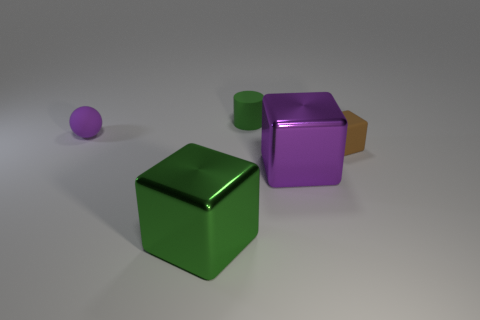Are there any other things that are the same shape as the purple matte object?
Provide a succinct answer. No. Are the small purple ball and the big object on the left side of the green rubber object made of the same material?
Provide a succinct answer. No. There is a thing in front of the purple thing that is to the right of the purple thing that is behind the brown matte block; what is its color?
Your answer should be compact. Green. What shape is the purple metal object that is the same size as the green block?
Your answer should be compact. Cube. Is there any other thing that is the same size as the green cube?
Make the answer very short. Yes. Does the block that is in front of the big purple shiny block have the same size as the purple object in front of the brown block?
Offer a very short reply. Yes. What size is the purple object to the right of the large green metal cube?
Your answer should be compact. Large. What is the color of the thing that is the same size as the purple shiny cube?
Give a very brief answer. Green. Does the cylinder have the same size as the brown cube?
Your answer should be very brief. Yes. There is a thing that is both behind the tiny cube and on the left side of the green cylinder; what is its size?
Make the answer very short. Small. 